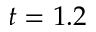Convert formula to latex. <formula><loc_0><loc_0><loc_500><loc_500>t = 1 . 2</formula> 